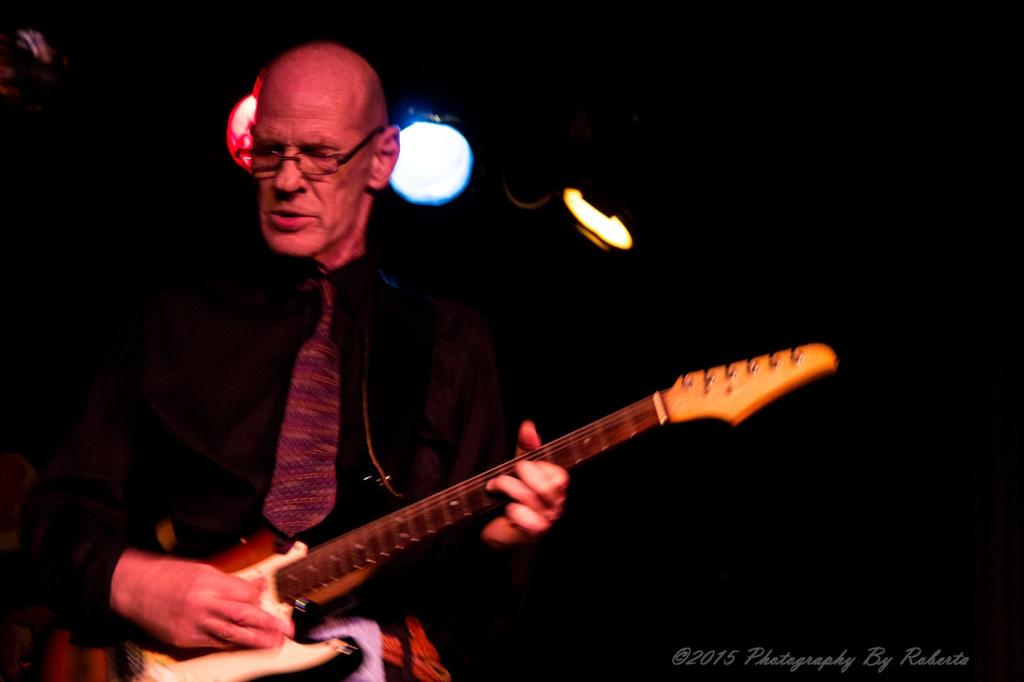What is the person in the image doing? The person is holding a guitar. What object is the person holding in the image? The person is holding a guitar. What can be seen in the background of the image? There are lights visible in the background of the image. How many fingers is the person pointing at the sun in the image? There is no sun present in the image, and the person is not pointing at anything. 